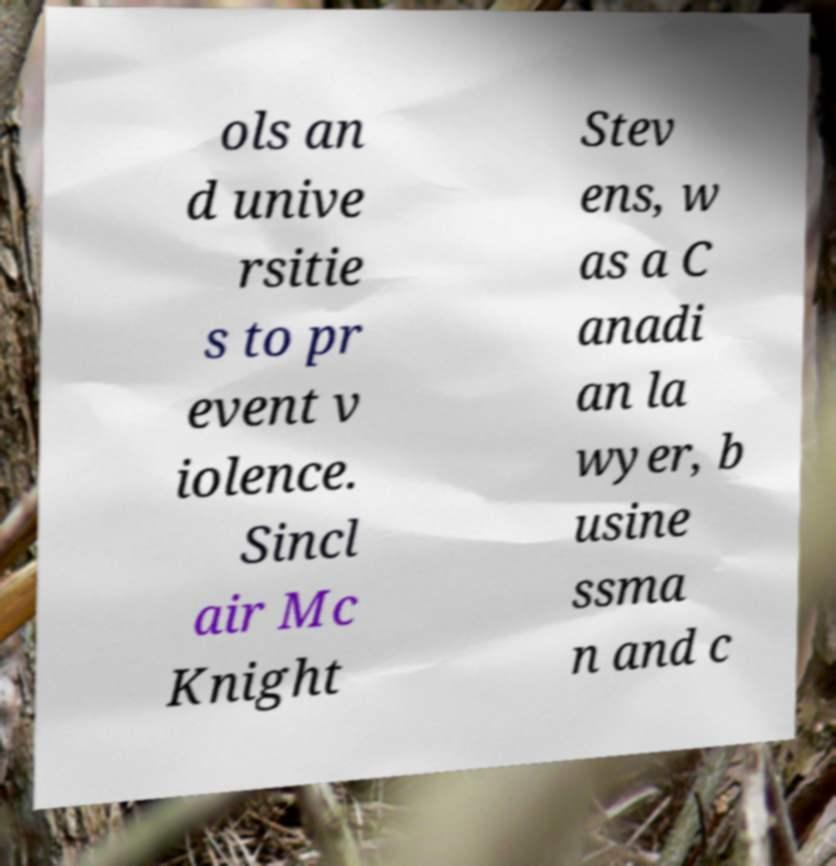Please identify and transcribe the text found in this image. ols an d unive rsitie s to pr event v iolence. Sincl air Mc Knight Stev ens, w as a C anadi an la wyer, b usine ssma n and c 